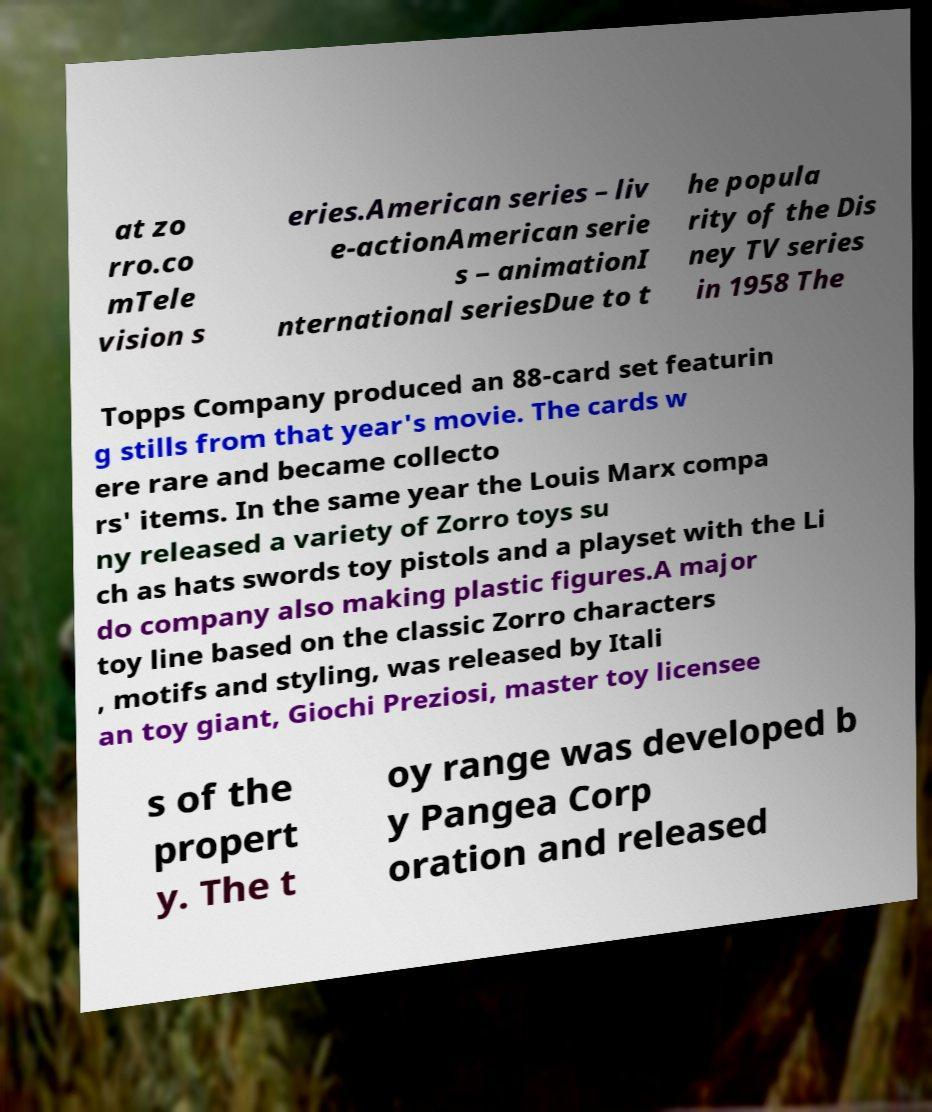Please identify and transcribe the text found in this image. at zo rro.co mTele vision s eries.American series – liv e-actionAmerican serie s – animationI nternational seriesDue to t he popula rity of the Dis ney TV series in 1958 The Topps Company produced an 88-card set featurin g stills from that year's movie. The cards w ere rare and became collecto rs' items. In the same year the Louis Marx compa ny released a variety of Zorro toys su ch as hats swords toy pistols and a playset with the Li do company also making plastic figures.A major toy line based on the classic Zorro characters , motifs and styling, was released by Itali an toy giant, Giochi Preziosi, master toy licensee s of the propert y. The t oy range was developed b y Pangea Corp oration and released 